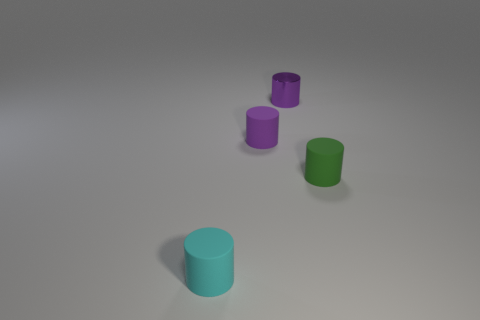Add 1 big brown blocks. How many objects exist? 5 Subtract all purple metal cylinders. How many cylinders are left? 3 Subtract all gray balls. How many purple cylinders are left? 2 Subtract all purple cylinders. How many cylinders are left? 2 Subtract 1 cylinders. How many cylinders are left? 3 Add 4 small purple things. How many small purple things are left? 6 Add 4 matte objects. How many matte objects exist? 7 Subtract 0 blue spheres. How many objects are left? 4 Subtract all green cylinders. Subtract all brown balls. How many cylinders are left? 3 Subtract all tiny cyan things. Subtract all rubber objects. How many objects are left? 0 